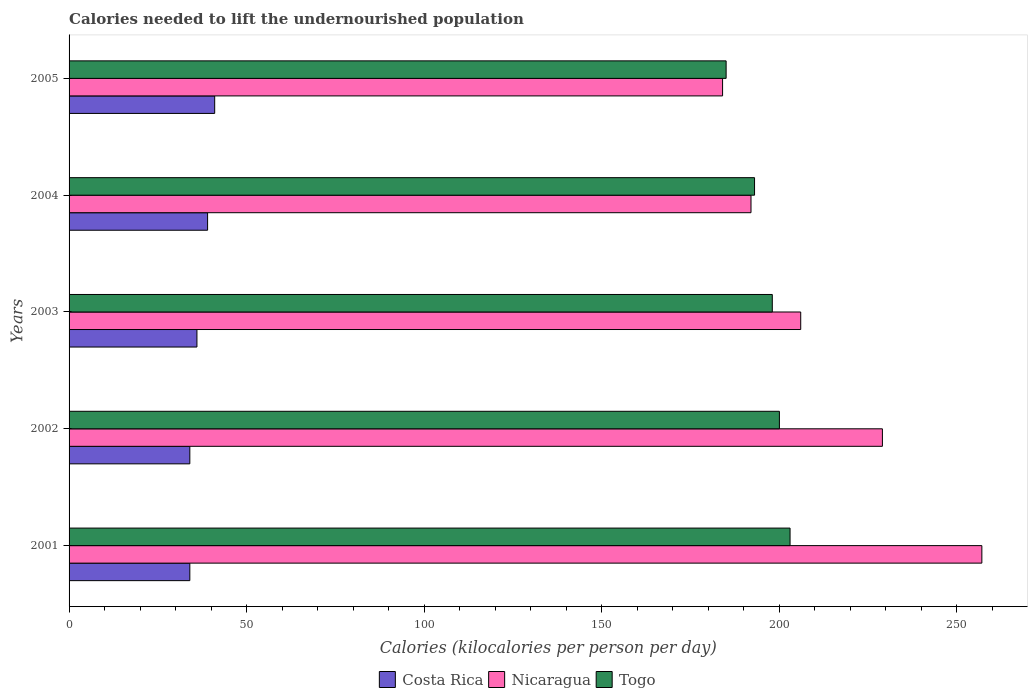How many bars are there on the 3rd tick from the top?
Your answer should be very brief. 3. How many bars are there on the 5th tick from the bottom?
Your answer should be very brief. 3. What is the label of the 2nd group of bars from the top?
Ensure brevity in your answer.  2004. In how many cases, is the number of bars for a given year not equal to the number of legend labels?
Your response must be concise. 0. What is the total calories needed to lift the undernourished population in Nicaragua in 2004?
Give a very brief answer. 192. Across all years, what is the maximum total calories needed to lift the undernourished population in Costa Rica?
Your response must be concise. 41. Across all years, what is the minimum total calories needed to lift the undernourished population in Nicaragua?
Your response must be concise. 184. What is the total total calories needed to lift the undernourished population in Togo in the graph?
Make the answer very short. 979. What is the difference between the total calories needed to lift the undernourished population in Togo in 2001 and that in 2002?
Your answer should be compact. 3. What is the difference between the total calories needed to lift the undernourished population in Costa Rica in 2001 and the total calories needed to lift the undernourished population in Nicaragua in 2003?
Your answer should be very brief. -172. What is the average total calories needed to lift the undernourished population in Togo per year?
Give a very brief answer. 195.8. In the year 2002, what is the difference between the total calories needed to lift the undernourished population in Nicaragua and total calories needed to lift the undernourished population in Togo?
Your answer should be very brief. 29. In how many years, is the total calories needed to lift the undernourished population in Costa Rica greater than 20 kilocalories?
Provide a succinct answer. 5. What is the ratio of the total calories needed to lift the undernourished population in Nicaragua in 2003 to that in 2004?
Offer a very short reply. 1.07. Is the total calories needed to lift the undernourished population in Costa Rica in 2002 less than that in 2004?
Your answer should be compact. Yes. What is the difference between the highest and the lowest total calories needed to lift the undernourished population in Costa Rica?
Give a very brief answer. 7. What does the 2nd bar from the top in 2002 represents?
Provide a succinct answer. Nicaragua. What does the 2nd bar from the bottom in 2005 represents?
Keep it short and to the point. Nicaragua. Is it the case that in every year, the sum of the total calories needed to lift the undernourished population in Togo and total calories needed to lift the undernourished population in Nicaragua is greater than the total calories needed to lift the undernourished population in Costa Rica?
Make the answer very short. Yes. How many bars are there?
Keep it short and to the point. 15. Are all the bars in the graph horizontal?
Offer a terse response. Yes. What is the difference between two consecutive major ticks on the X-axis?
Make the answer very short. 50. What is the title of the graph?
Keep it short and to the point. Calories needed to lift the undernourished population. What is the label or title of the X-axis?
Your answer should be compact. Calories (kilocalories per person per day). What is the Calories (kilocalories per person per day) in Costa Rica in 2001?
Your answer should be very brief. 34. What is the Calories (kilocalories per person per day) of Nicaragua in 2001?
Provide a short and direct response. 257. What is the Calories (kilocalories per person per day) in Togo in 2001?
Your response must be concise. 203. What is the Calories (kilocalories per person per day) in Nicaragua in 2002?
Offer a very short reply. 229. What is the Calories (kilocalories per person per day) in Togo in 2002?
Your response must be concise. 200. What is the Calories (kilocalories per person per day) of Costa Rica in 2003?
Provide a succinct answer. 36. What is the Calories (kilocalories per person per day) in Nicaragua in 2003?
Your response must be concise. 206. What is the Calories (kilocalories per person per day) in Togo in 2003?
Give a very brief answer. 198. What is the Calories (kilocalories per person per day) of Nicaragua in 2004?
Offer a terse response. 192. What is the Calories (kilocalories per person per day) in Togo in 2004?
Provide a short and direct response. 193. What is the Calories (kilocalories per person per day) of Costa Rica in 2005?
Give a very brief answer. 41. What is the Calories (kilocalories per person per day) in Nicaragua in 2005?
Keep it short and to the point. 184. What is the Calories (kilocalories per person per day) of Togo in 2005?
Offer a very short reply. 185. Across all years, what is the maximum Calories (kilocalories per person per day) in Nicaragua?
Keep it short and to the point. 257. Across all years, what is the maximum Calories (kilocalories per person per day) in Togo?
Give a very brief answer. 203. Across all years, what is the minimum Calories (kilocalories per person per day) of Costa Rica?
Your response must be concise. 34. Across all years, what is the minimum Calories (kilocalories per person per day) of Nicaragua?
Keep it short and to the point. 184. Across all years, what is the minimum Calories (kilocalories per person per day) of Togo?
Your response must be concise. 185. What is the total Calories (kilocalories per person per day) of Costa Rica in the graph?
Your answer should be compact. 184. What is the total Calories (kilocalories per person per day) in Nicaragua in the graph?
Your answer should be compact. 1068. What is the total Calories (kilocalories per person per day) of Togo in the graph?
Provide a succinct answer. 979. What is the difference between the Calories (kilocalories per person per day) in Costa Rica in 2001 and that in 2002?
Provide a succinct answer. 0. What is the difference between the Calories (kilocalories per person per day) in Nicaragua in 2001 and that in 2002?
Give a very brief answer. 28. What is the difference between the Calories (kilocalories per person per day) of Togo in 2001 and that in 2003?
Your answer should be compact. 5. What is the difference between the Calories (kilocalories per person per day) in Nicaragua in 2001 and that in 2004?
Your response must be concise. 65. What is the difference between the Calories (kilocalories per person per day) of Togo in 2001 and that in 2004?
Ensure brevity in your answer.  10. What is the difference between the Calories (kilocalories per person per day) in Costa Rica in 2001 and that in 2005?
Your response must be concise. -7. What is the difference between the Calories (kilocalories per person per day) in Nicaragua in 2001 and that in 2005?
Your answer should be compact. 73. What is the difference between the Calories (kilocalories per person per day) in Togo in 2001 and that in 2005?
Provide a short and direct response. 18. What is the difference between the Calories (kilocalories per person per day) of Costa Rica in 2002 and that in 2003?
Your answer should be compact. -2. What is the difference between the Calories (kilocalories per person per day) of Nicaragua in 2002 and that in 2003?
Your answer should be compact. 23. What is the difference between the Calories (kilocalories per person per day) in Togo in 2002 and that in 2005?
Ensure brevity in your answer.  15. What is the difference between the Calories (kilocalories per person per day) in Costa Rica in 2003 and that in 2004?
Your answer should be very brief. -3. What is the difference between the Calories (kilocalories per person per day) in Togo in 2003 and that in 2004?
Provide a succinct answer. 5. What is the difference between the Calories (kilocalories per person per day) of Costa Rica in 2003 and that in 2005?
Make the answer very short. -5. What is the difference between the Calories (kilocalories per person per day) of Togo in 2003 and that in 2005?
Your response must be concise. 13. What is the difference between the Calories (kilocalories per person per day) in Togo in 2004 and that in 2005?
Make the answer very short. 8. What is the difference between the Calories (kilocalories per person per day) of Costa Rica in 2001 and the Calories (kilocalories per person per day) of Nicaragua in 2002?
Make the answer very short. -195. What is the difference between the Calories (kilocalories per person per day) of Costa Rica in 2001 and the Calories (kilocalories per person per day) of Togo in 2002?
Offer a terse response. -166. What is the difference between the Calories (kilocalories per person per day) in Costa Rica in 2001 and the Calories (kilocalories per person per day) in Nicaragua in 2003?
Your answer should be compact. -172. What is the difference between the Calories (kilocalories per person per day) of Costa Rica in 2001 and the Calories (kilocalories per person per day) of Togo in 2003?
Offer a very short reply. -164. What is the difference between the Calories (kilocalories per person per day) of Nicaragua in 2001 and the Calories (kilocalories per person per day) of Togo in 2003?
Your answer should be compact. 59. What is the difference between the Calories (kilocalories per person per day) of Costa Rica in 2001 and the Calories (kilocalories per person per day) of Nicaragua in 2004?
Offer a very short reply. -158. What is the difference between the Calories (kilocalories per person per day) in Costa Rica in 2001 and the Calories (kilocalories per person per day) in Togo in 2004?
Your response must be concise. -159. What is the difference between the Calories (kilocalories per person per day) in Nicaragua in 2001 and the Calories (kilocalories per person per day) in Togo in 2004?
Offer a terse response. 64. What is the difference between the Calories (kilocalories per person per day) of Costa Rica in 2001 and the Calories (kilocalories per person per day) of Nicaragua in 2005?
Keep it short and to the point. -150. What is the difference between the Calories (kilocalories per person per day) in Costa Rica in 2001 and the Calories (kilocalories per person per day) in Togo in 2005?
Make the answer very short. -151. What is the difference between the Calories (kilocalories per person per day) in Nicaragua in 2001 and the Calories (kilocalories per person per day) in Togo in 2005?
Your answer should be very brief. 72. What is the difference between the Calories (kilocalories per person per day) in Costa Rica in 2002 and the Calories (kilocalories per person per day) in Nicaragua in 2003?
Provide a short and direct response. -172. What is the difference between the Calories (kilocalories per person per day) of Costa Rica in 2002 and the Calories (kilocalories per person per day) of Togo in 2003?
Make the answer very short. -164. What is the difference between the Calories (kilocalories per person per day) in Nicaragua in 2002 and the Calories (kilocalories per person per day) in Togo in 2003?
Give a very brief answer. 31. What is the difference between the Calories (kilocalories per person per day) of Costa Rica in 2002 and the Calories (kilocalories per person per day) of Nicaragua in 2004?
Ensure brevity in your answer.  -158. What is the difference between the Calories (kilocalories per person per day) of Costa Rica in 2002 and the Calories (kilocalories per person per day) of Togo in 2004?
Provide a succinct answer. -159. What is the difference between the Calories (kilocalories per person per day) in Nicaragua in 2002 and the Calories (kilocalories per person per day) in Togo in 2004?
Your answer should be very brief. 36. What is the difference between the Calories (kilocalories per person per day) in Costa Rica in 2002 and the Calories (kilocalories per person per day) in Nicaragua in 2005?
Make the answer very short. -150. What is the difference between the Calories (kilocalories per person per day) of Costa Rica in 2002 and the Calories (kilocalories per person per day) of Togo in 2005?
Your response must be concise. -151. What is the difference between the Calories (kilocalories per person per day) in Costa Rica in 2003 and the Calories (kilocalories per person per day) in Nicaragua in 2004?
Keep it short and to the point. -156. What is the difference between the Calories (kilocalories per person per day) in Costa Rica in 2003 and the Calories (kilocalories per person per day) in Togo in 2004?
Ensure brevity in your answer.  -157. What is the difference between the Calories (kilocalories per person per day) in Nicaragua in 2003 and the Calories (kilocalories per person per day) in Togo in 2004?
Provide a short and direct response. 13. What is the difference between the Calories (kilocalories per person per day) in Costa Rica in 2003 and the Calories (kilocalories per person per day) in Nicaragua in 2005?
Make the answer very short. -148. What is the difference between the Calories (kilocalories per person per day) of Costa Rica in 2003 and the Calories (kilocalories per person per day) of Togo in 2005?
Provide a short and direct response. -149. What is the difference between the Calories (kilocalories per person per day) in Costa Rica in 2004 and the Calories (kilocalories per person per day) in Nicaragua in 2005?
Keep it short and to the point. -145. What is the difference between the Calories (kilocalories per person per day) in Costa Rica in 2004 and the Calories (kilocalories per person per day) in Togo in 2005?
Your answer should be compact. -146. What is the average Calories (kilocalories per person per day) in Costa Rica per year?
Provide a succinct answer. 36.8. What is the average Calories (kilocalories per person per day) in Nicaragua per year?
Offer a very short reply. 213.6. What is the average Calories (kilocalories per person per day) in Togo per year?
Offer a terse response. 195.8. In the year 2001, what is the difference between the Calories (kilocalories per person per day) in Costa Rica and Calories (kilocalories per person per day) in Nicaragua?
Give a very brief answer. -223. In the year 2001, what is the difference between the Calories (kilocalories per person per day) in Costa Rica and Calories (kilocalories per person per day) in Togo?
Provide a succinct answer. -169. In the year 2002, what is the difference between the Calories (kilocalories per person per day) of Costa Rica and Calories (kilocalories per person per day) of Nicaragua?
Provide a succinct answer. -195. In the year 2002, what is the difference between the Calories (kilocalories per person per day) in Costa Rica and Calories (kilocalories per person per day) in Togo?
Offer a terse response. -166. In the year 2002, what is the difference between the Calories (kilocalories per person per day) in Nicaragua and Calories (kilocalories per person per day) in Togo?
Ensure brevity in your answer.  29. In the year 2003, what is the difference between the Calories (kilocalories per person per day) in Costa Rica and Calories (kilocalories per person per day) in Nicaragua?
Your response must be concise. -170. In the year 2003, what is the difference between the Calories (kilocalories per person per day) in Costa Rica and Calories (kilocalories per person per day) in Togo?
Give a very brief answer. -162. In the year 2004, what is the difference between the Calories (kilocalories per person per day) in Costa Rica and Calories (kilocalories per person per day) in Nicaragua?
Make the answer very short. -153. In the year 2004, what is the difference between the Calories (kilocalories per person per day) of Costa Rica and Calories (kilocalories per person per day) of Togo?
Your answer should be very brief. -154. In the year 2004, what is the difference between the Calories (kilocalories per person per day) of Nicaragua and Calories (kilocalories per person per day) of Togo?
Your response must be concise. -1. In the year 2005, what is the difference between the Calories (kilocalories per person per day) in Costa Rica and Calories (kilocalories per person per day) in Nicaragua?
Offer a terse response. -143. In the year 2005, what is the difference between the Calories (kilocalories per person per day) in Costa Rica and Calories (kilocalories per person per day) in Togo?
Your answer should be very brief. -144. What is the ratio of the Calories (kilocalories per person per day) of Nicaragua in 2001 to that in 2002?
Your response must be concise. 1.12. What is the ratio of the Calories (kilocalories per person per day) in Togo in 2001 to that in 2002?
Provide a succinct answer. 1.01. What is the ratio of the Calories (kilocalories per person per day) in Costa Rica in 2001 to that in 2003?
Your answer should be compact. 0.94. What is the ratio of the Calories (kilocalories per person per day) in Nicaragua in 2001 to that in 2003?
Make the answer very short. 1.25. What is the ratio of the Calories (kilocalories per person per day) of Togo in 2001 to that in 2003?
Your answer should be very brief. 1.03. What is the ratio of the Calories (kilocalories per person per day) in Costa Rica in 2001 to that in 2004?
Ensure brevity in your answer.  0.87. What is the ratio of the Calories (kilocalories per person per day) of Nicaragua in 2001 to that in 2004?
Offer a terse response. 1.34. What is the ratio of the Calories (kilocalories per person per day) of Togo in 2001 to that in 2004?
Offer a very short reply. 1.05. What is the ratio of the Calories (kilocalories per person per day) of Costa Rica in 2001 to that in 2005?
Provide a short and direct response. 0.83. What is the ratio of the Calories (kilocalories per person per day) in Nicaragua in 2001 to that in 2005?
Keep it short and to the point. 1.4. What is the ratio of the Calories (kilocalories per person per day) in Togo in 2001 to that in 2005?
Your response must be concise. 1.1. What is the ratio of the Calories (kilocalories per person per day) of Nicaragua in 2002 to that in 2003?
Your response must be concise. 1.11. What is the ratio of the Calories (kilocalories per person per day) in Togo in 2002 to that in 2003?
Ensure brevity in your answer.  1.01. What is the ratio of the Calories (kilocalories per person per day) of Costa Rica in 2002 to that in 2004?
Your answer should be compact. 0.87. What is the ratio of the Calories (kilocalories per person per day) of Nicaragua in 2002 to that in 2004?
Offer a terse response. 1.19. What is the ratio of the Calories (kilocalories per person per day) in Togo in 2002 to that in 2004?
Offer a very short reply. 1.04. What is the ratio of the Calories (kilocalories per person per day) of Costa Rica in 2002 to that in 2005?
Your response must be concise. 0.83. What is the ratio of the Calories (kilocalories per person per day) in Nicaragua in 2002 to that in 2005?
Ensure brevity in your answer.  1.24. What is the ratio of the Calories (kilocalories per person per day) in Togo in 2002 to that in 2005?
Ensure brevity in your answer.  1.08. What is the ratio of the Calories (kilocalories per person per day) in Costa Rica in 2003 to that in 2004?
Offer a terse response. 0.92. What is the ratio of the Calories (kilocalories per person per day) of Nicaragua in 2003 to that in 2004?
Give a very brief answer. 1.07. What is the ratio of the Calories (kilocalories per person per day) of Togo in 2003 to that in 2004?
Provide a short and direct response. 1.03. What is the ratio of the Calories (kilocalories per person per day) of Costa Rica in 2003 to that in 2005?
Offer a terse response. 0.88. What is the ratio of the Calories (kilocalories per person per day) of Nicaragua in 2003 to that in 2005?
Provide a succinct answer. 1.12. What is the ratio of the Calories (kilocalories per person per day) of Togo in 2003 to that in 2005?
Give a very brief answer. 1.07. What is the ratio of the Calories (kilocalories per person per day) in Costa Rica in 2004 to that in 2005?
Give a very brief answer. 0.95. What is the ratio of the Calories (kilocalories per person per day) in Nicaragua in 2004 to that in 2005?
Give a very brief answer. 1.04. What is the ratio of the Calories (kilocalories per person per day) of Togo in 2004 to that in 2005?
Offer a very short reply. 1.04. What is the difference between the highest and the second highest Calories (kilocalories per person per day) of Costa Rica?
Offer a terse response. 2. What is the difference between the highest and the second highest Calories (kilocalories per person per day) of Togo?
Ensure brevity in your answer.  3. What is the difference between the highest and the lowest Calories (kilocalories per person per day) of Nicaragua?
Ensure brevity in your answer.  73. What is the difference between the highest and the lowest Calories (kilocalories per person per day) in Togo?
Provide a short and direct response. 18. 